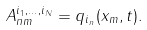Convert formula to latex. <formula><loc_0><loc_0><loc_500><loc_500>A ^ { i _ { 1 } , \dots , i _ { N } } _ { n m } = q _ { i _ { n } } ( x _ { m } , t ) .</formula> 